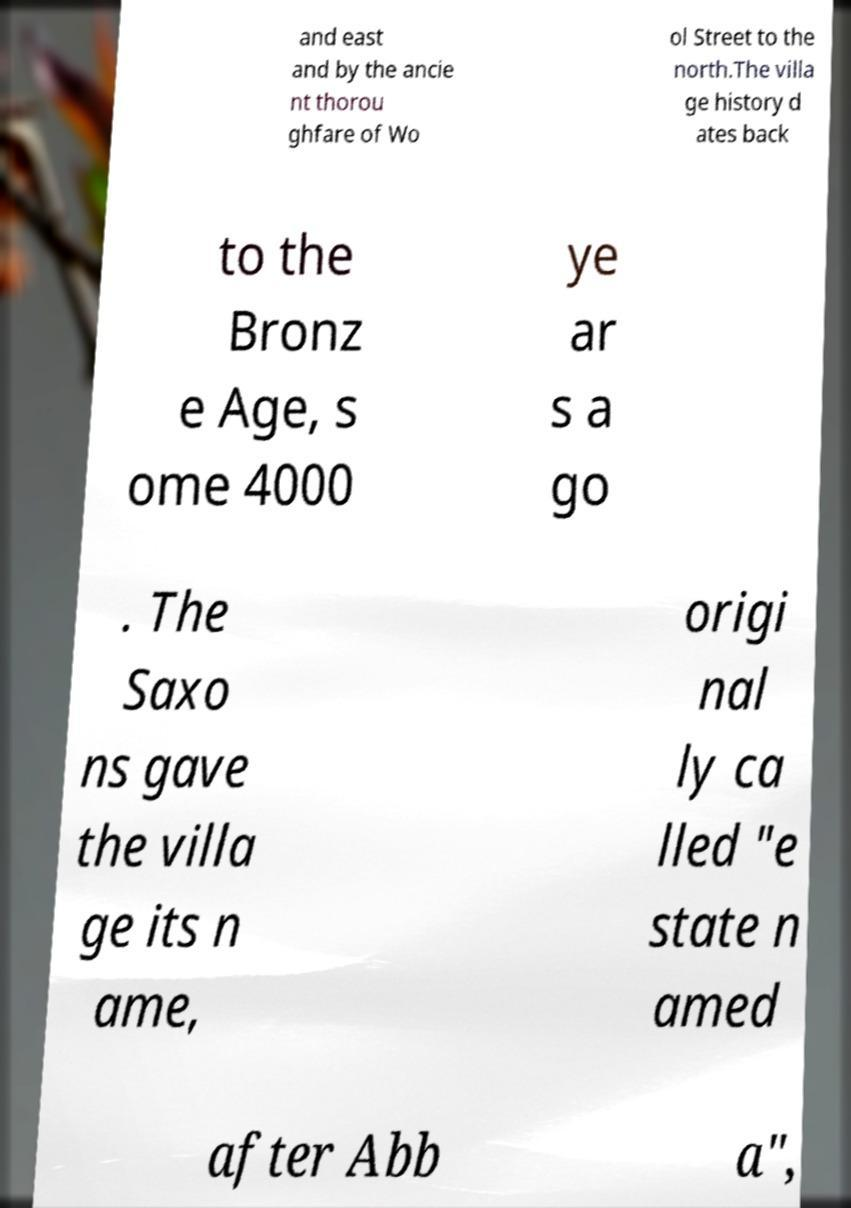What messages or text are displayed in this image? I need them in a readable, typed format. and east and by the ancie nt thorou ghfare of Wo ol Street to the north.The villa ge history d ates back to the Bronz e Age, s ome 4000 ye ar s a go . The Saxo ns gave the villa ge its n ame, origi nal ly ca lled "e state n amed after Abb a", 